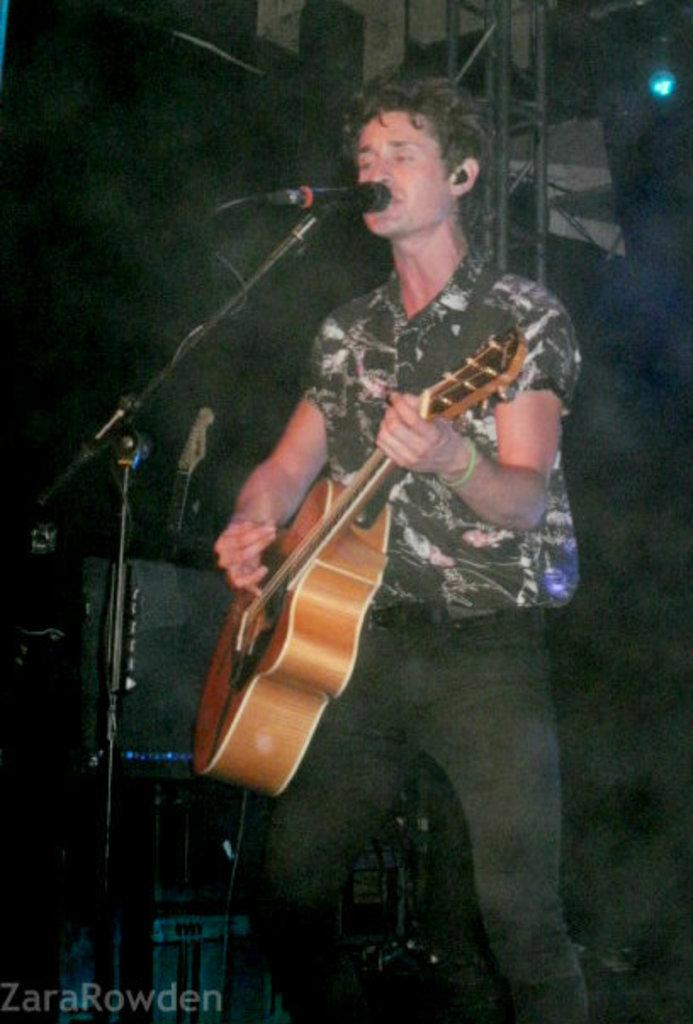What is the man in the image doing? The man is playing a guitar. What object is the man positioned near? The man is in front of a microphone. What can be seen in the background of the image? There are metal rods and lights in the background of the image. Where is the lunchroom in the image? There is no lunchroom present in the image. How many women are visible in the image? There are no women visible in the image; it features a man playing a guitar. 